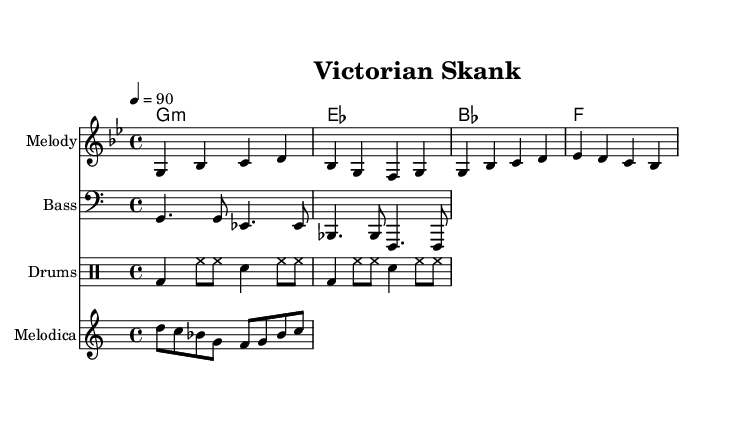What is the key signature of this music? The key signature is G minor, which contains two flats (B♭ and E♭). This can be determined by looking for the key signature indicated at the beginning of the score.
Answer: G minor What is the time signature of this score? The time signature is 4/4, indicated at the beginning of the music. This means there are four beats in each measure and a quarter note gets one beat.
Answer: 4/4 What is the tempo indication of the piece? The tempo is set at 90 beats per minute, as indicated by "4 = 90". This provides the speed at which the piece should be performed.
Answer: 90 How many measures are in the melody? There are four measures in the melody section, which is shown by counting the number of vertical bar lines present in the melody staff.
Answer: 4 What is the bass line's clef? The bass line is written in bass clef, which is used for lower pitches and is indicated at the beginning of the bass staff.
Answer: Bass What genre does this music belong to? This music is a reggae fusion, which is characterized by its rhythmic style and influence from both Victorian-era elements and Caribbean culture. Though the sheet music doesn’t explicitly state the genre, the rhythmic patterns and musical elements reflect this genre.
Answer: Reggae How do the chords in the harmony section relate to the melody? The chords in the harmony section (G minor, E♭, B♭, and F) provide harmonic support to the melody, emphasizing the key and adding depth to the musical texture. The chords correspond with the melody notes, enriching the overall sound.
Answer: They support the melody 